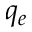<formula> <loc_0><loc_0><loc_500><loc_500>q _ { e }</formula> 